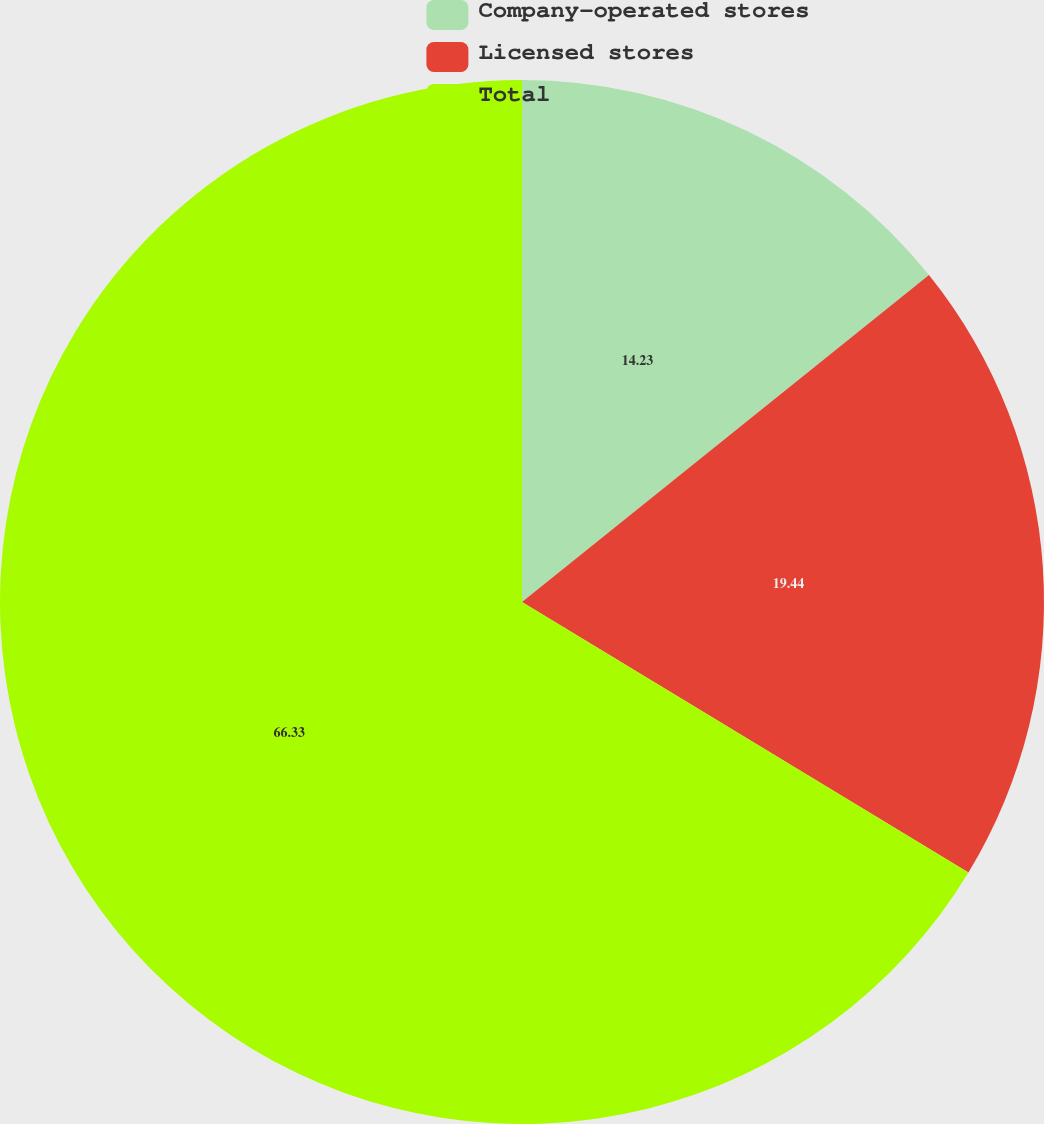Convert chart. <chart><loc_0><loc_0><loc_500><loc_500><pie_chart><fcel>Company-operated stores<fcel>Licensed stores<fcel>Total<nl><fcel>14.23%<fcel>19.44%<fcel>66.33%<nl></chart> 